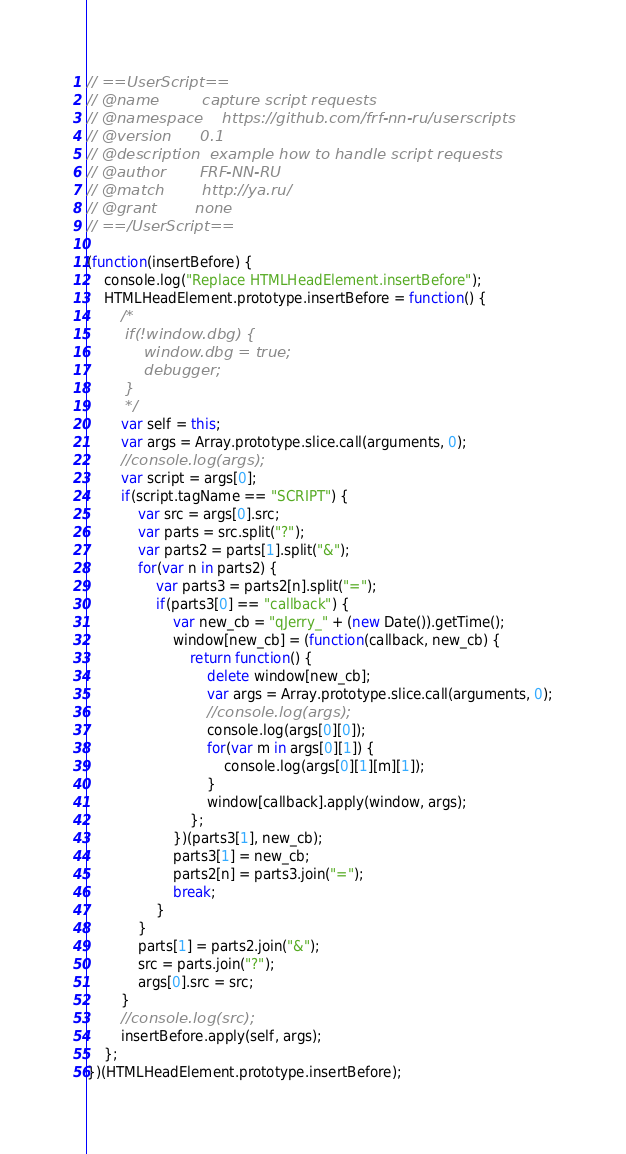Convert code to text. <code><loc_0><loc_0><loc_500><loc_500><_JavaScript_>// ==UserScript==
// @name         capture script requests
// @namespace    https://github.com/frf-nn-ru/userscripts
// @version      0.1
// @description  example how to handle script requests
// @author       FRF-NN-RU
// @match        http://ya.ru/
// @grant        none
// ==/UserScript==

(function(insertBefore) {
    console.log("Replace HTMLHeadElement.insertBefore");
    HTMLHeadElement.prototype.insertBefore = function() {
        /*
        if(!window.dbg) {
            window.dbg = true;
            debugger;
        }
        */
        var self = this;
        var args = Array.prototype.slice.call(arguments, 0);
        //console.log(args);
        var script = args[0];
        if(script.tagName == "SCRIPT") {
            var src = args[0].src;
            var parts = src.split("?");
            var parts2 = parts[1].split("&");
            for(var n in parts2) {
                var parts3 = parts2[n].split("=");
                if(parts3[0] == "callback") {
                    var new_cb = "qJerry_" + (new Date()).getTime();
                    window[new_cb] = (function(callback, new_cb) {
                        return function() {
                            delete window[new_cb];
                            var args = Array.prototype.slice.call(arguments, 0);
                            //console.log(args);
                            console.log(args[0][0]);
                            for(var m in args[0][1]) {
                                console.log(args[0][1][m][1]);
                            }
                            window[callback].apply(window, args);
                        };
                    })(parts3[1], new_cb);
                    parts3[1] = new_cb;
                    parts2[n] = parts3.join("=");
                    break;
                }
            }
            parts[1] = parts2.join("&");
            src = parts.join("?");
            args[0].src = src;
        }
        //console.log(src);
        insertBefore.apply(self, args);
    };
})(HTMLHeadElement.prototype.insertBefore);
</code> 